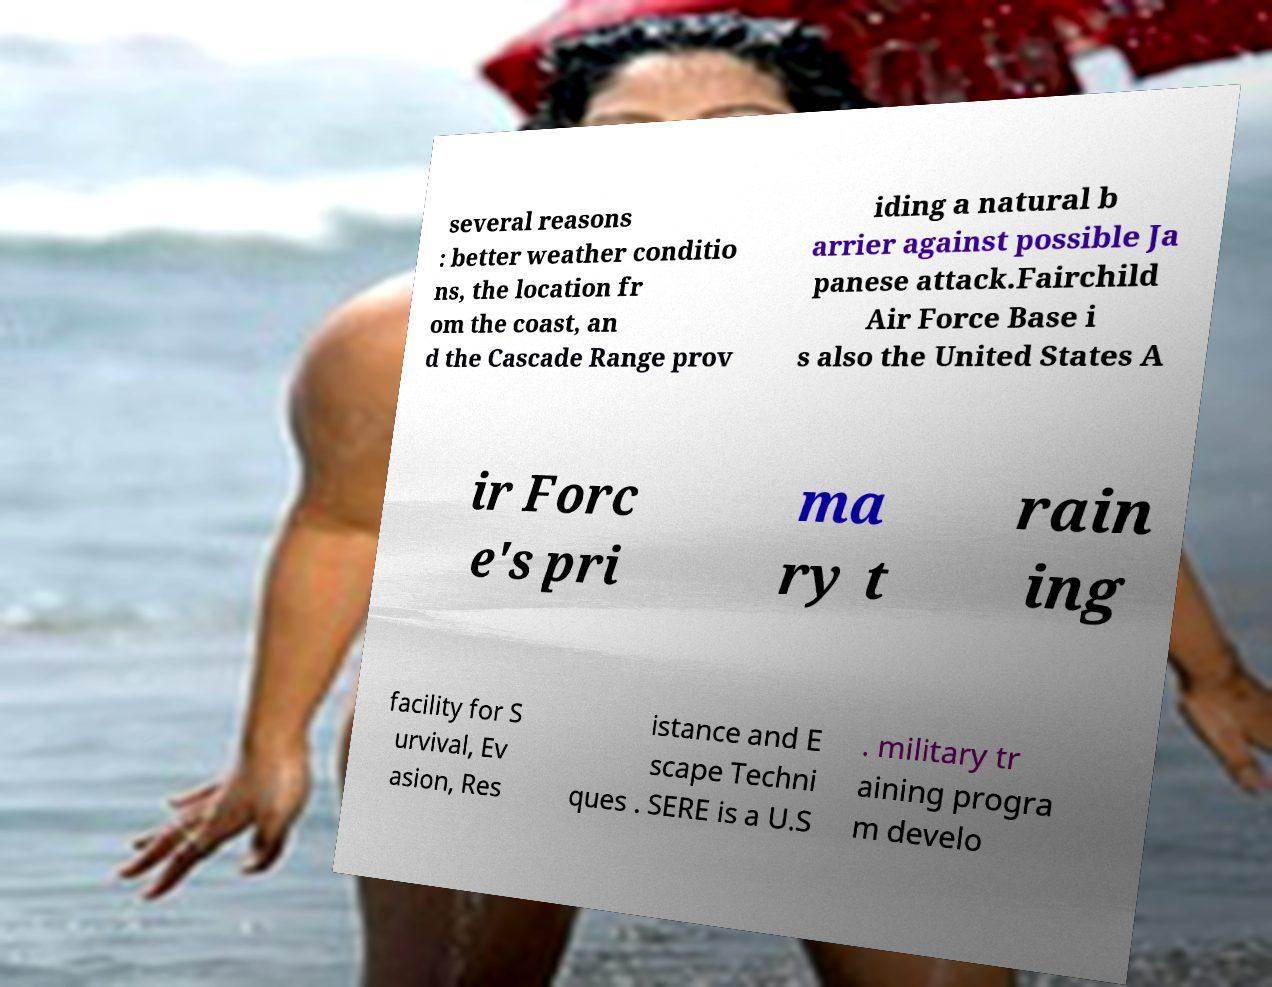Could you assist in decoding the text presented in this image and type it out clearly? several reasons : better weather conditio ns, the location fr om the coast, an d the Cascade Range prov iding a natural b arrier against possible Ja panese attack.Fairchild Air Force Base i s also the United States A ir Forc e's pri ma ry t rain ing facility for S urvival, Ev asion, Res istance and E scape Techni ques . SERE is a U.S . military tr aining progra m develo 